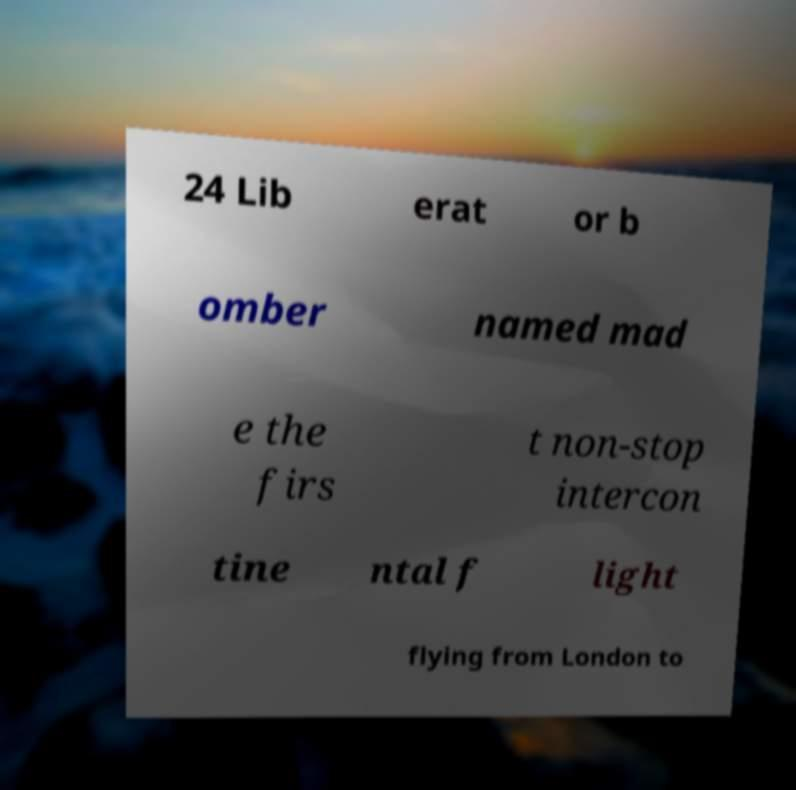What messages or text are displayed in this image? I need them in a readable, typed format. 24 Lib erat or b omber named mad e the firs t non-stop intercon tine ntal f light flying from London to 